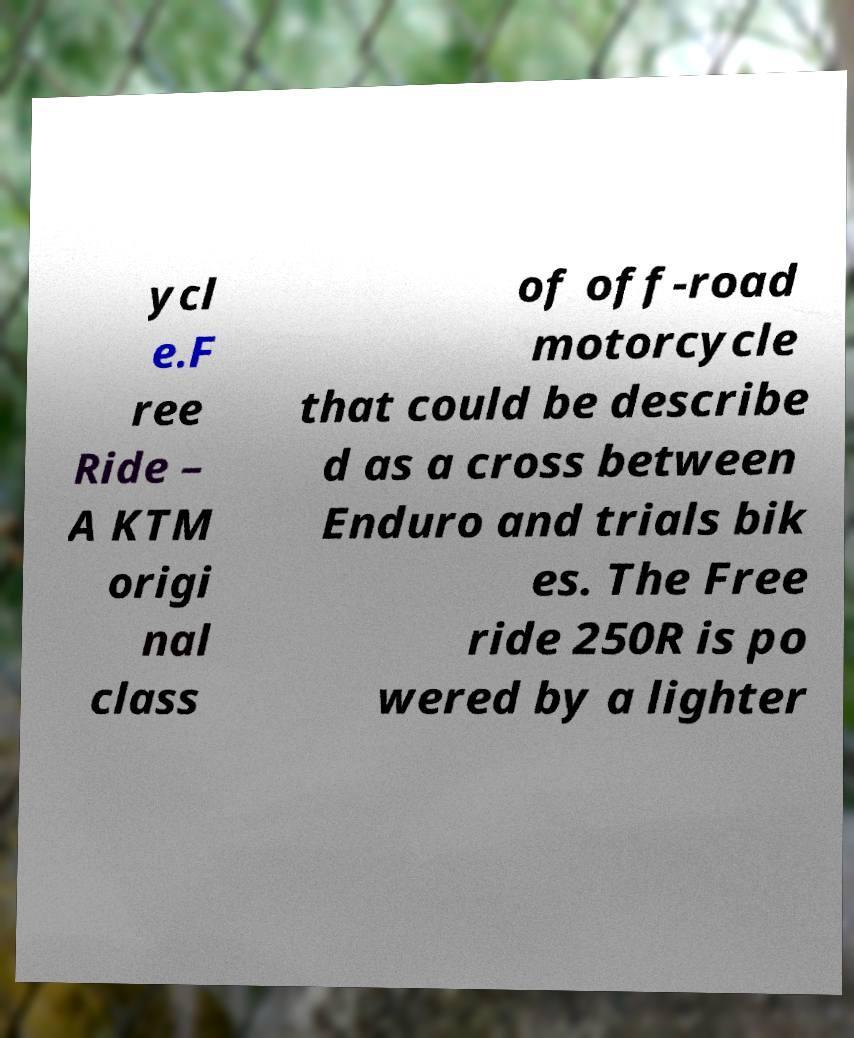What messages or text are displayed in this image? I need them in a readable, typed format. ycl e.F ree Ride – A KTM origi nal class of off-road motorcycle that could be describe d as a cross between Enduro and trials bik es. The Free ride 250R is po wered by a lighter 